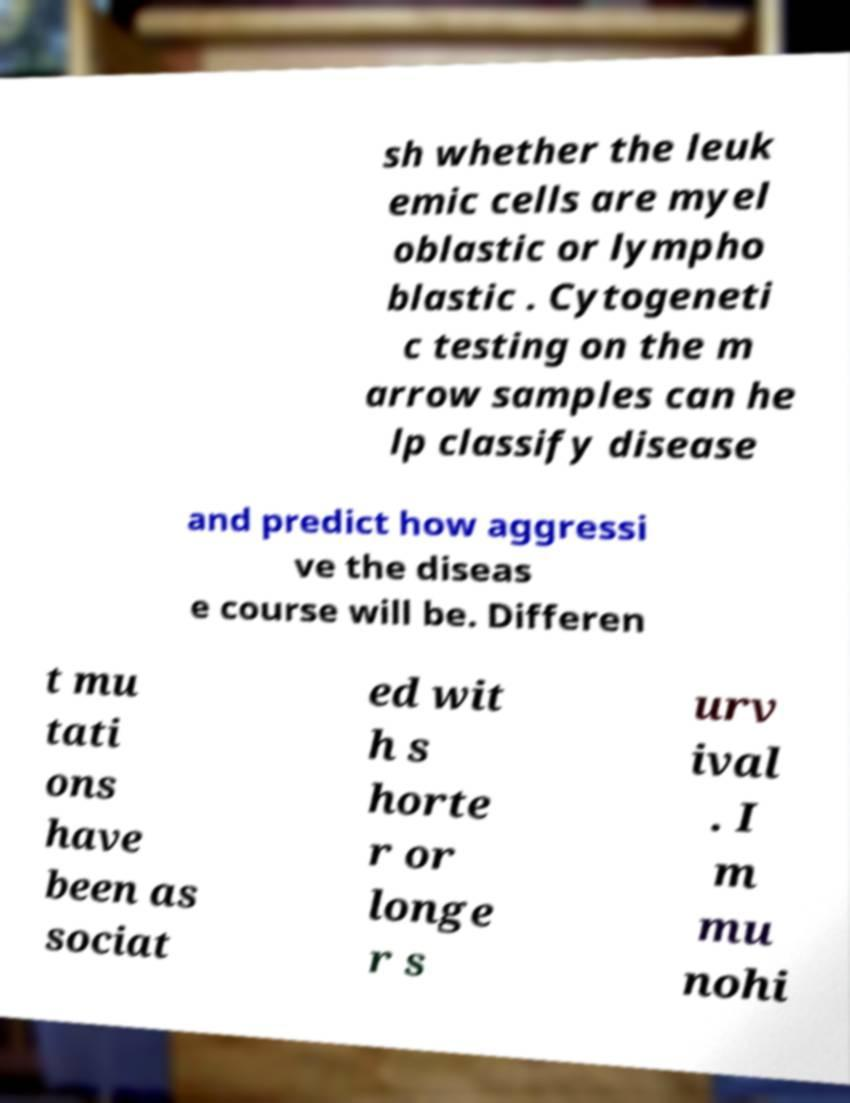There's text embedded in this image that I need extracted. Can you transcribe it verbatim? sh whether the leuk emic cells are myel oblastic or lympho blastic . Cytogeneti c testing on the m arrow samples can he lp classify disease and predict how aggressi ve the diseas e course will be. Differen t mu tati ons have been as sociat ed wit h s horte r or longe r s urv ival . I m mu nohi 